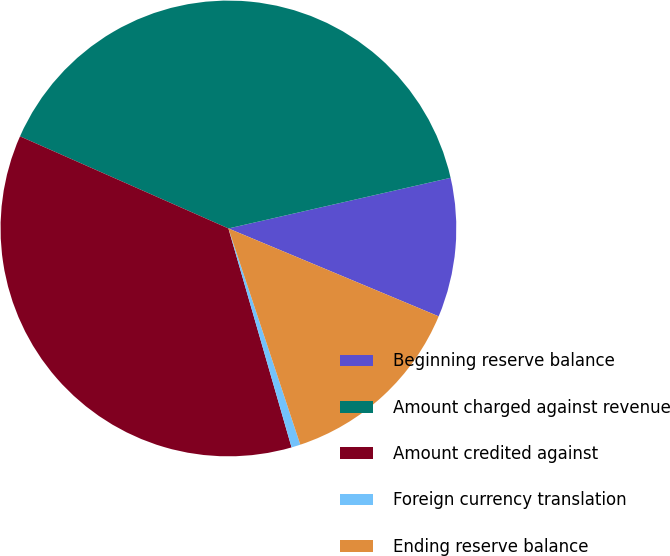Convert chart. <chart><loc_0><loc_0><loc_500><loc_500><pie_chart><fcel>Beginning reserve balance<fcel>Amount charged against revenue<fcel>Amount credited against<fcel>Foreign currency translation<fcel>Ending reserve balance<nl><fcel>9.87%<fcel>39.81%<fcel>36.09%<fcel>0.64%<fcel>13.59%<nl></chart> 